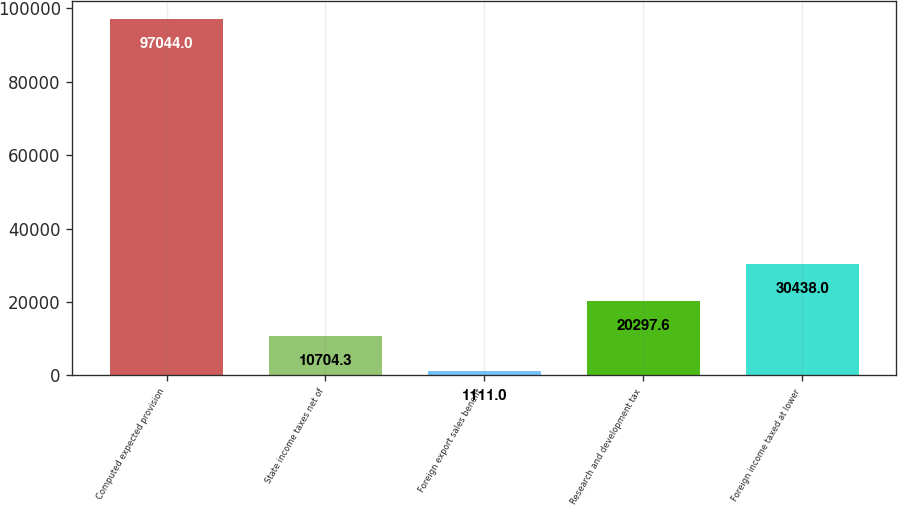Convert chart. <chart><loc_0><loc_0><loc_500><loc_500><bar_chart><fcel>Computed expected provision<fcel>State income taxes net of<fcel>Foreign export sales benefit<fcel>Research and development tax<fcel>Foreign income taxed at lower<nl><fcel>97044<fcel>10704.3<fcel>1111<fcel>20297.6<fcel>30438<nl></chart> 